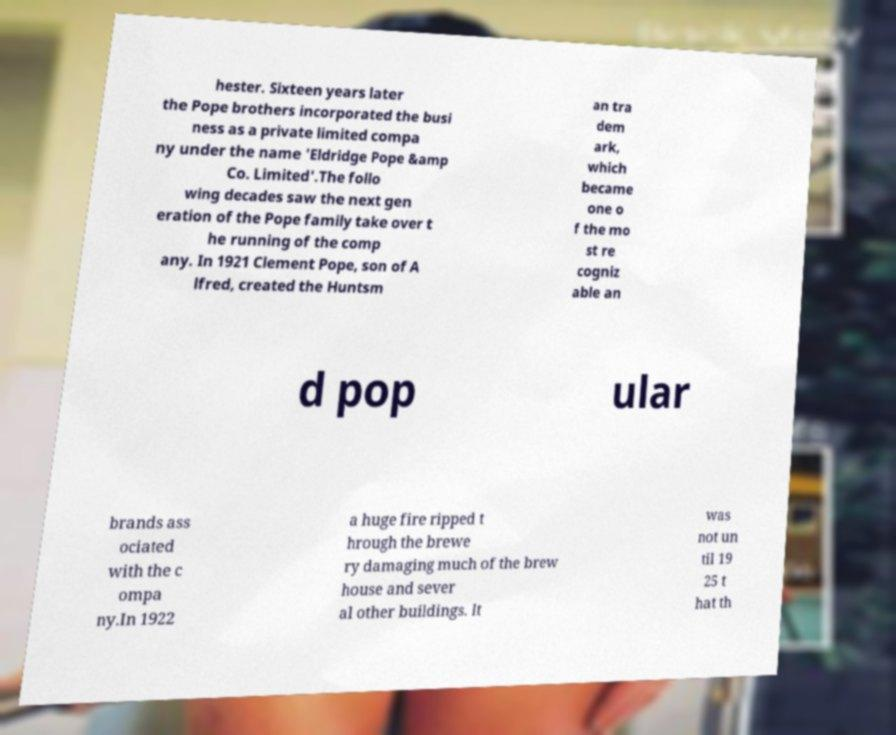Could you assist in decoding the text presented in this image and type it out clearly? hester. Sixteen years later the Pope brothers incorporated the busi ness as a private limited compa ny under the name 'Eldridge Pope &amp Co. Limited'.The follo wing decades saw the next gen eration of the Pope family take over t he running of the comp any. In 1921 Clement Pope, son of A lfred, created the Huntsm an tra dem ark, which became one o f the mo st re cogniz able an d pop ular brands ass ociated with the c ompa ny.In 1922 a huge fire ripped t hrough the brewe ry damaging much of the brew house and sever al other buildings. It was not un til 19 25 t hat th 